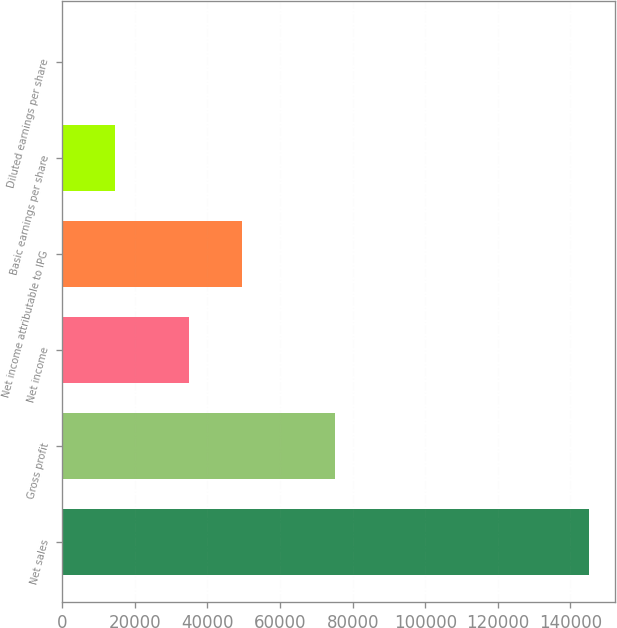<chart> <loc_0><loc_0><loc_500><loc_500><bar_chart><fcel>Net sales<fcel>Gross profit<fcel>Net income<fcel>Net income attributable to IPG<fcel>Basic earnings per share<fcel>Diluted earnings per share<nl><fcel>145030<fcel>75174<fcel>34912<fcel>49414.9<fcel>14503.6<fcel>0.67<nl></chart> 